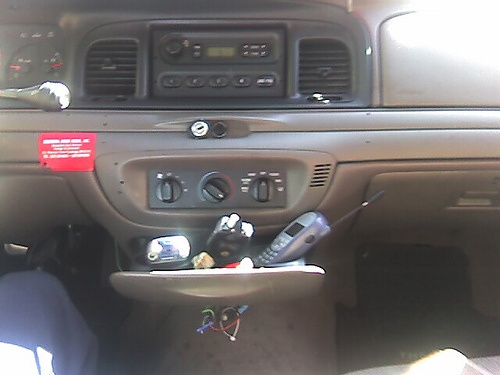Describe the objects in this image and their specific colors. I can see people in gray, black, and white tones and cell phone in gray and darkgray tones in this image. 